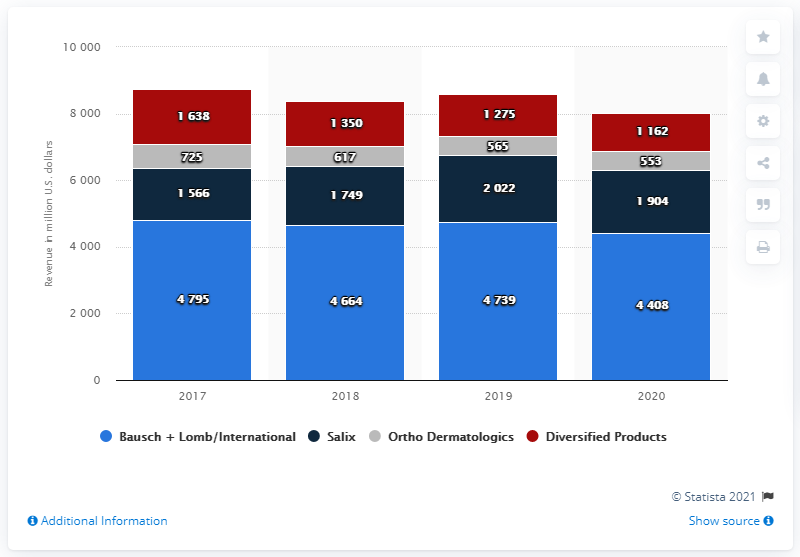Identify some key points in this picture. Ortho Dermatologics generated an estimated revenue of 553 million dollars in 2020. 